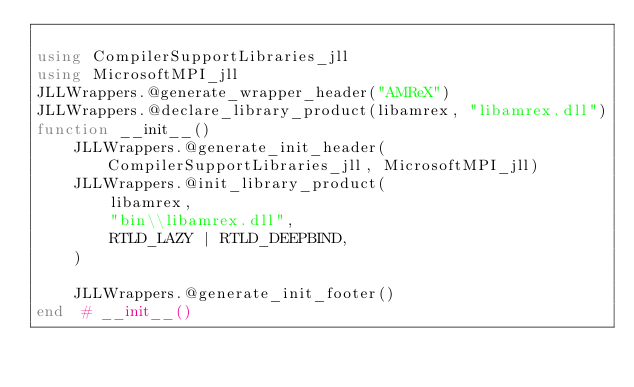<code> <loc_0><loc_0><loc_500><loc_500><_Julia_>
using CompilerSupportLibraries_jll
using MicrosoftMPI_jll
JLLWrappers.@generate_wrapper_header("AMReX")
JLLWrappers.@declare_library_product(libamrex, "libamrex.dll")
function __init__()
    JLLWrappers.@generate_init_header(CompilerSupportLibraries_jll, MicrosoftMPI_jll)
    JLLWrappers.@init_library_product(
        libamrex,
        "bin\\libamrex.dll",
        RTLD_LAZY | RTLD_DEEPBIND,
    )

    JLLWrappers.@generate_init_footer()
end  # __init__()
</code> 